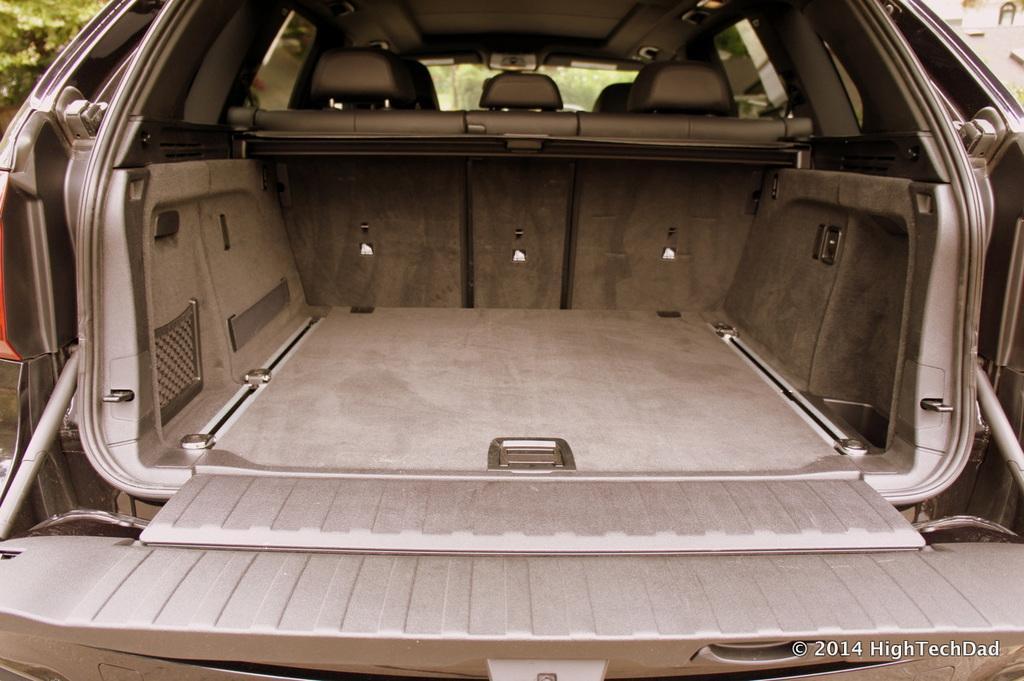Describe this image in one or two sentences. In this image we can see an inside view of the car, in front here is the windshield, there are the trees. 